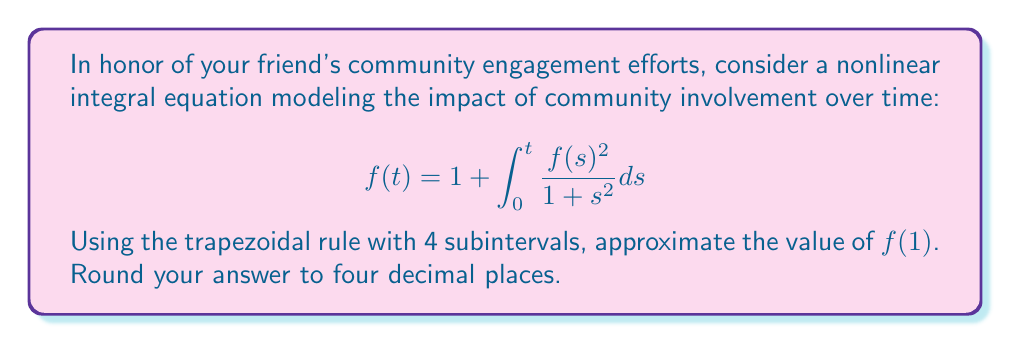Provide a solution to this math problem. 1) First, we need to set up the trapezoidal rule for numerical integration:

   $$\int_a^b g(x)dx \approx \frac{h}{2}[g(x_0) + 2g(x_1) + 2g(x_2) + ... + 2g(x_{n-1}) + g(x_n)]$$

   where $h = \frac{b-a}{n}$, and $n$ is the number of subintervals.

2) In our case, $a=0$, $b=1$, and $n=4$. So $h = \frac{1-0}{4} = 0.25$.

3) We need to evaluate $f(t)$ at $t = 0, 0.25, 0.5, 0.75, 1$.

4) Let's start with $f(0) = 1$ (given in the equation).

5) For the other points, we'll use the trapezoidal rule iteratively:

   $f(0.25) \approx 1 + \frac{0.25}{2}[\frac{1^2}{1+0^2} + \frac{f(0.25)^2}{1+0.25^2}]$

   $f(0.5) \approx 1 + \frac{0.25}{2}[\frac{1^2}{1+0^2} + 2\frac{f(0.25)^2}{1+0.25^2} + \frac{f(0.5)^2}{1+0.5^2}]$

   $f(0.75) \approx 1 + \frac{0.25}{2}[\frac{1^2}{1+0^2} + 2\frac{f(0.25)^2}{1+0.25^2} + 2\frac{f(0.5)^2}{1+0.5^2} + \frac{f(0.75)^2}{1+0.75^2}]$

   $f(1) \approx 1 + \frac{0.25}{2}[\frac{1^2}{1+0^2} + 2\frac{f(0.25)^2}{1+0.25^2} + 2\frac{f(0.5)^2}{1+0.5^2} + 2\frac{f(0.75)^2}{1+0.75^2} + \frac{f(1)^2}{1+1^2}]$

6) Solving these equations iteratively:

   $f(0.25) \approx 1.1180$
   $f(0.5) \approx 1.2493$
   $f(0.75) \approx 1.3933$
   $f(1) \approx 1.5500$

7) Rounding to four decimal places gives us the final answer.
Answer: 1.5500 